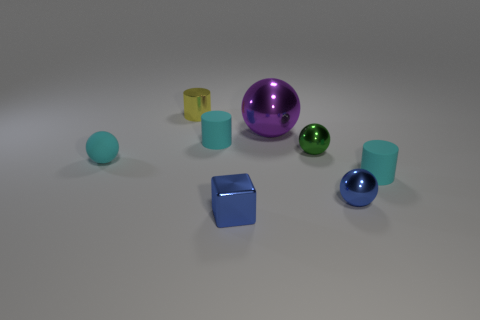Are there any tiny cyan matte balls?
Offer a terse response. Yes. There is a small cyan matte thing to the right of the blue metal thing that is to the left of the large purple sphere; what is its shape?
Ensure brevity in your answer.  Cylinder. How many things are blue objects behind the blue metal cube or rubber objects to the right of the yellow object?
Provide a short and direct response. 3. There is a blue ball that is the same size as the blue shiny block; what material is it?
Give a very brief answer. Metal. The small metal block is what color?
Provide a short and direct response. Blue. What material is the object that is both in front of the cyan ball and behind the blue ball?
Give a very brief answer. Rubber. Are there any things behind the cyan matte cylinder behind the cyan rubber cylinder in front of the small cyan rubber sphere?
Offer a terse response. Yes. What size is the shiny object that is the same color as the shiny cube?
Provide a succinct answer. Small. There is a small blue ball; are there any tiny blue shiny objects in front of it?
Your response must be concise. Yes. How many other things are there of the same shape as the big metallic thing?
Keep it short and to the point. 3. 